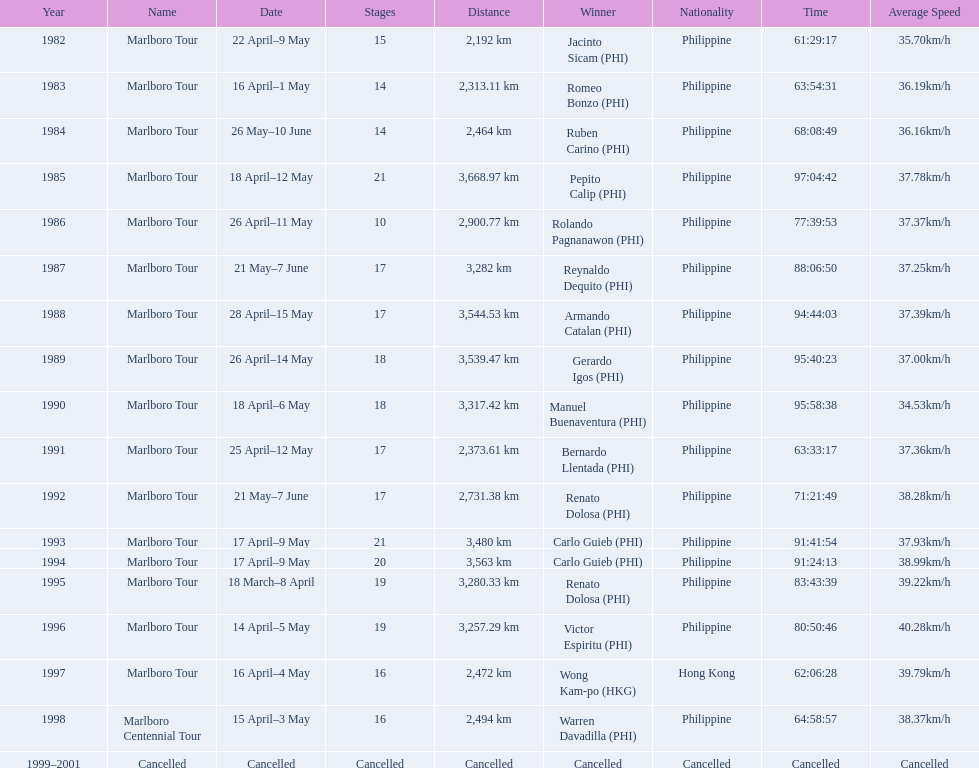Which year did warren davdilla (w.d.) appear? 1998. What tour did w.d. complete? Marlboro Centennial Tour. What is the time recorded in the same row as w.d.? 64:58:57. 